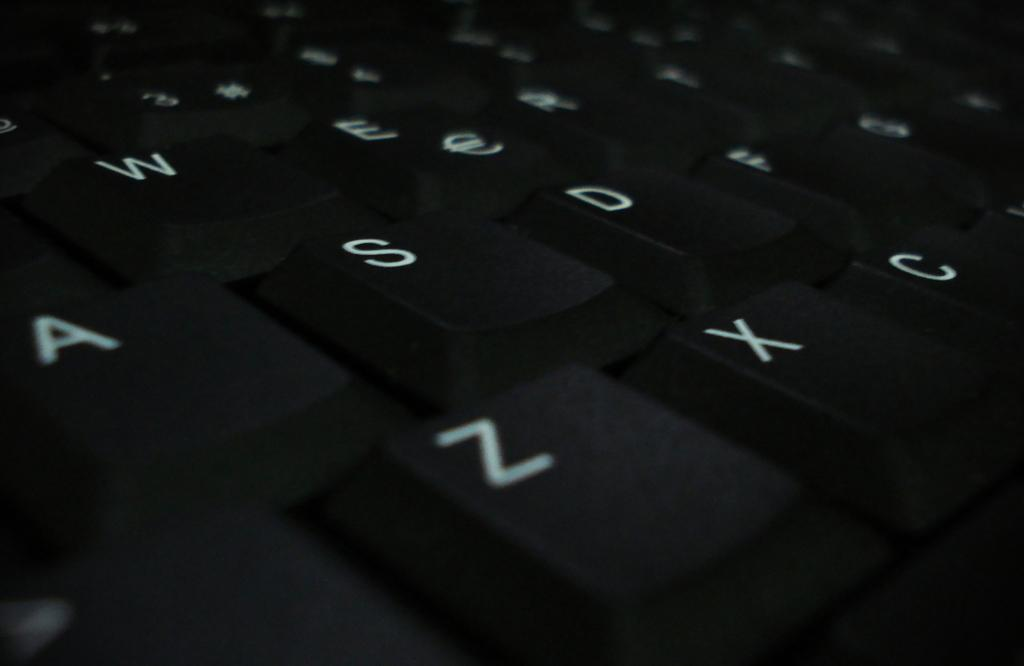<image>
Render a clear and concise summary of the photo. A close up of a keyboard showing letters Z, X, and C on the bottom row. 